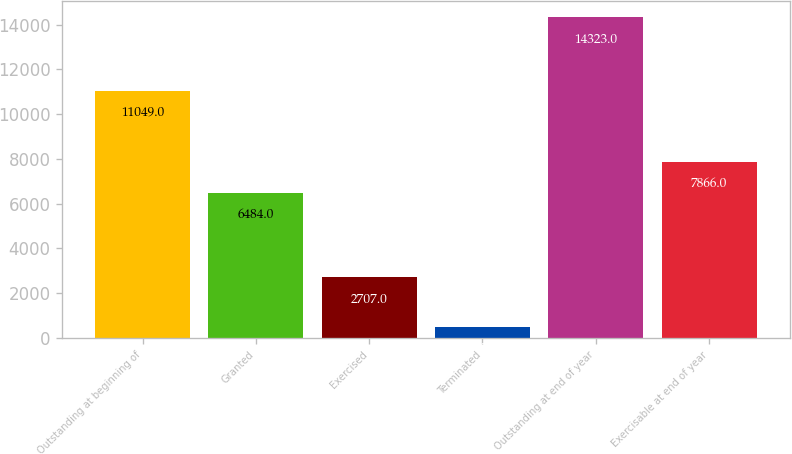Convert chart to OTSL. <chart><loc_0><loc_0><loc_500><loc_500><bar_chart><fcel>Outstanding at beginning of<fcel>Granted<fcel>Exercised<fcel>Terminated<fcel>Outstanding at end of year<fcel>Exercisable at end of year<nl><fcel>11049<fcel>6484<fcel>2707<fcel>503<fcel>14323<fcel>7866<nl></chart> 